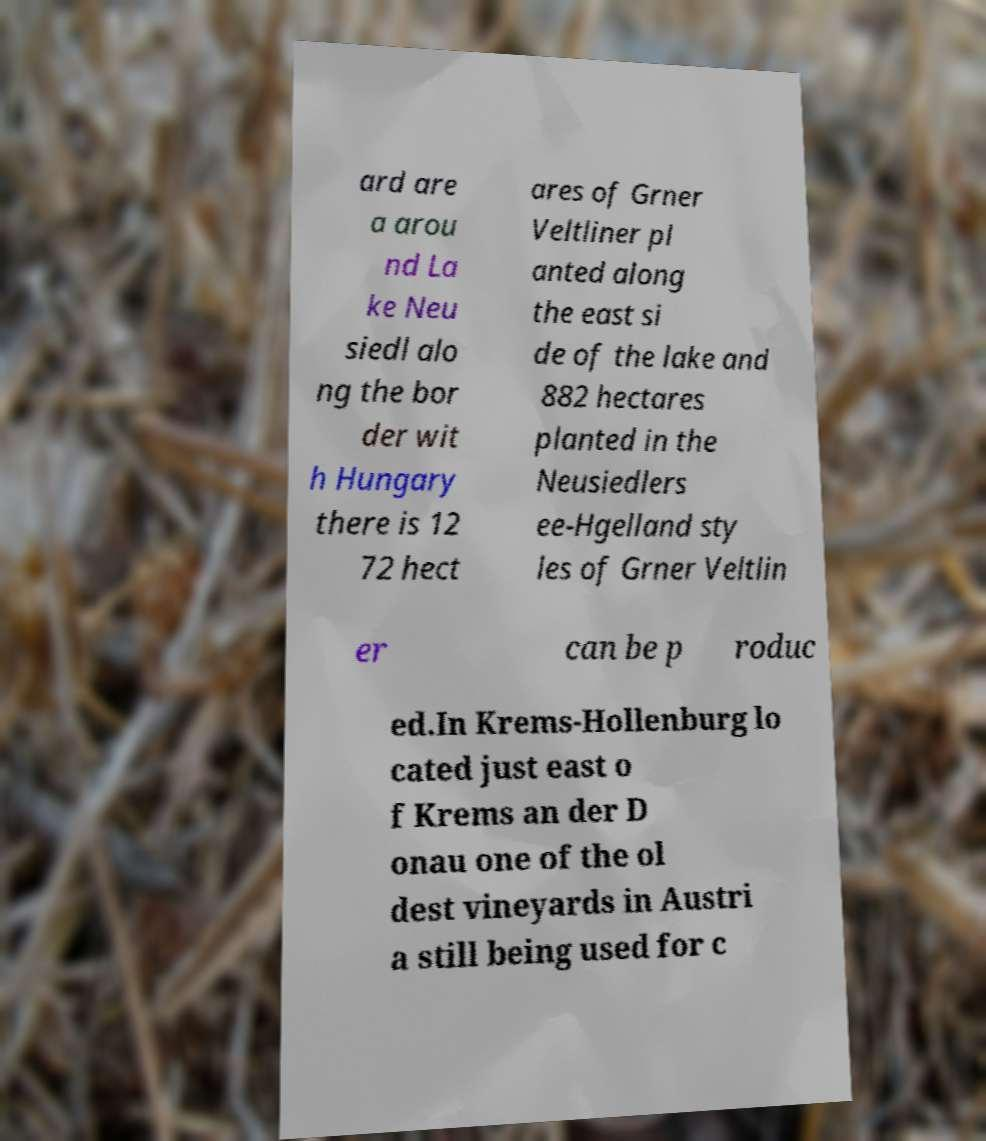For documentation purposes, I need the text within this image transcribed. Could you provide that? ard are a arou nd La ke Neu siedl alo ng the bor der wit h Hungary there is 12 72 hect ares of Grner Veltliner pl anted along the east si de of the lake and 882 hectares planted in the Neusiedlers ee-Hgelland sty les of Grner Veltlin er can be p roduc ed.In Krems-Hollenburg lo cated just east o f Krems an der D onau one of the ol dest vineyards in Austri a still being used for c 